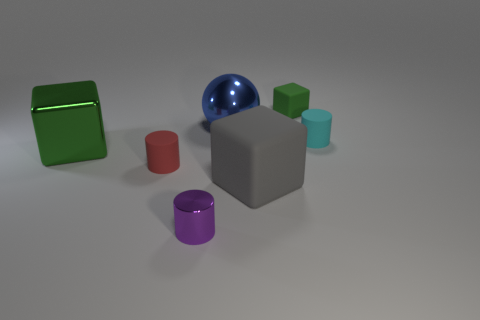If we were to interact with these objects, what sensory experiences might we encounter? Interacting with these objects would engage our sense of touch, with the potential for a variety of textures from the different materials. The coolness of the metal or plastic, the smoothness of each polished surface, and possibly the weight differences between the larger and smaller objects would contribute to a tactile exploration. 